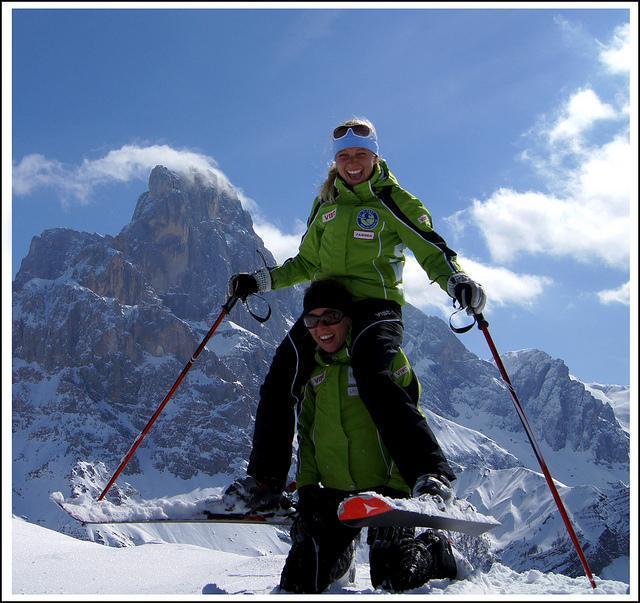How many people are visible?
Give a very brief answer. 2. 